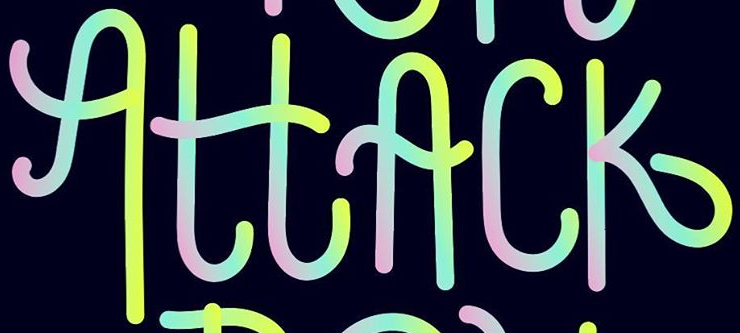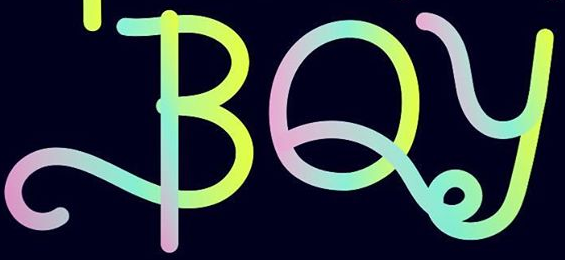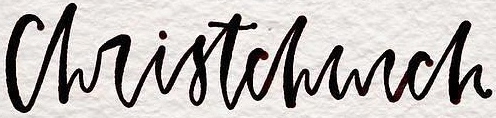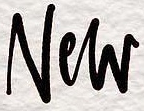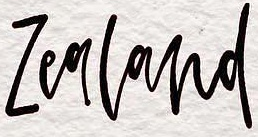Read the text content from these images in order, separated by a semicolon. AttAck; BOy; christchurch; New; Zealand 